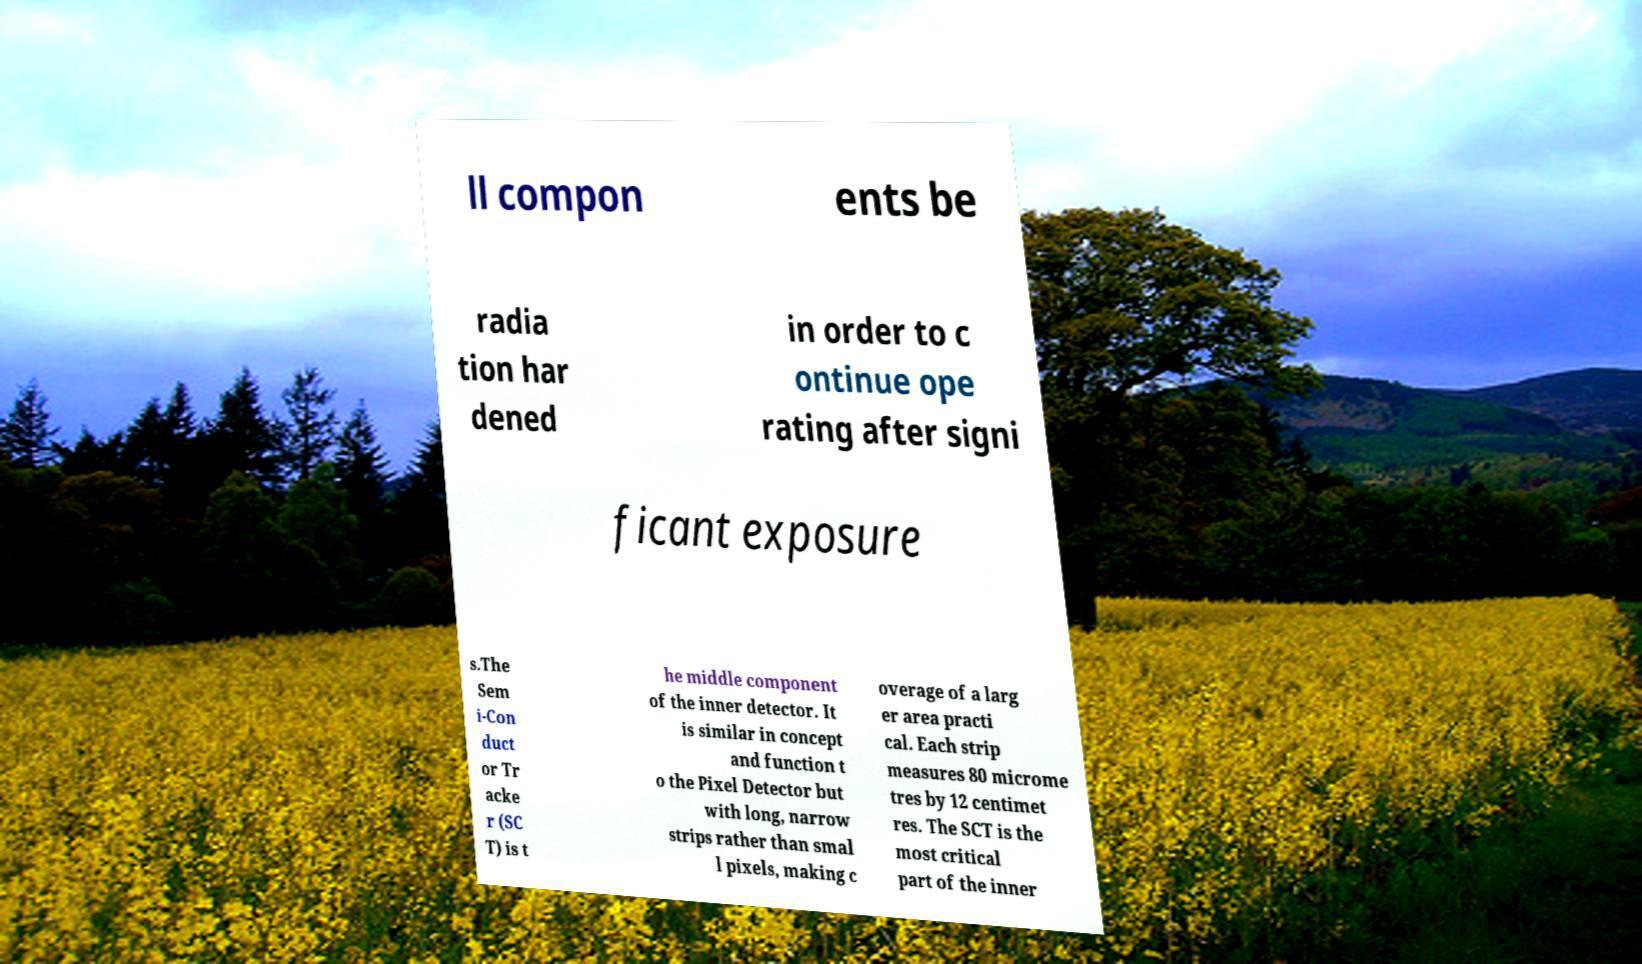What messages or text are displayed in this image? I need them in a readable, typed format. ll compon ents be radia tion har dened in order to c ontinue ope rating after signi ficant exposure s.The Sem i-Con duct or Tr acke r (SC T) is t he middle component of the inner detector. It is similar in concept and function t o the Pixel Detector but with long, narrow strips rather than smal l pixels, making c overage of a larg er area practi cal. Each strip measures 80 microme tres by 12 centimet res. The SCT is the most critical part of the inner 